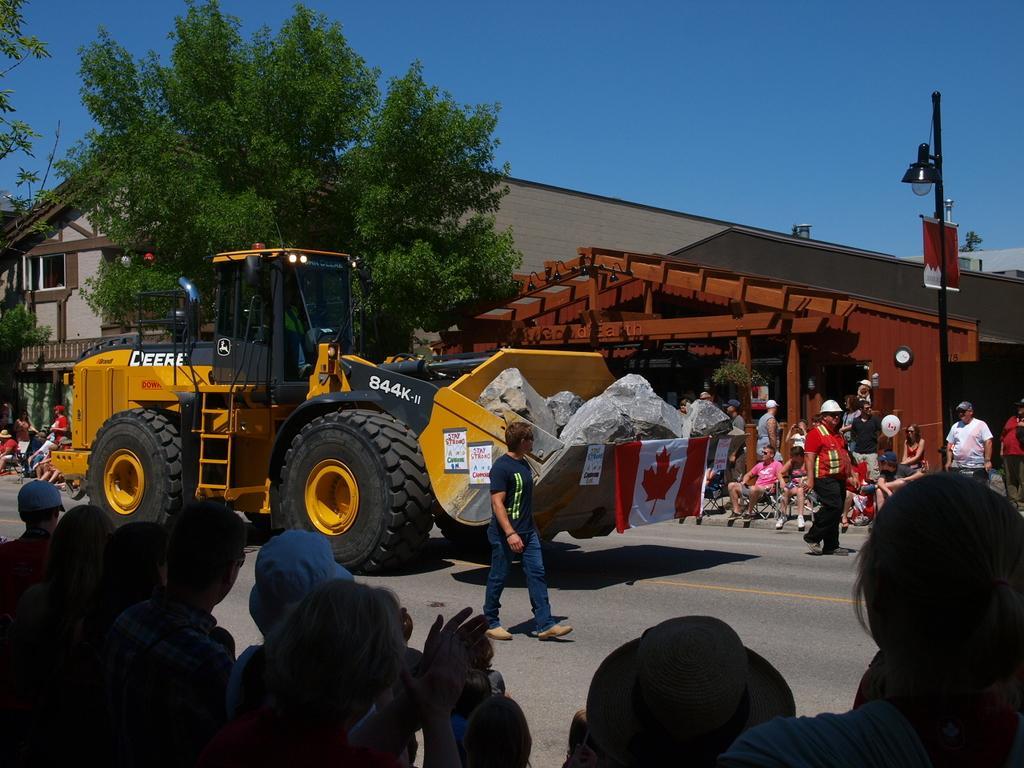How would you summarize this image in a sentence or two? In this image we can see a JCB with stones. On the JCB there is a flag. It is on the road. Also we can see many people on the sides of the road. In the back there are trees and buildings. Also there is a light pole. In the background there is sky. 